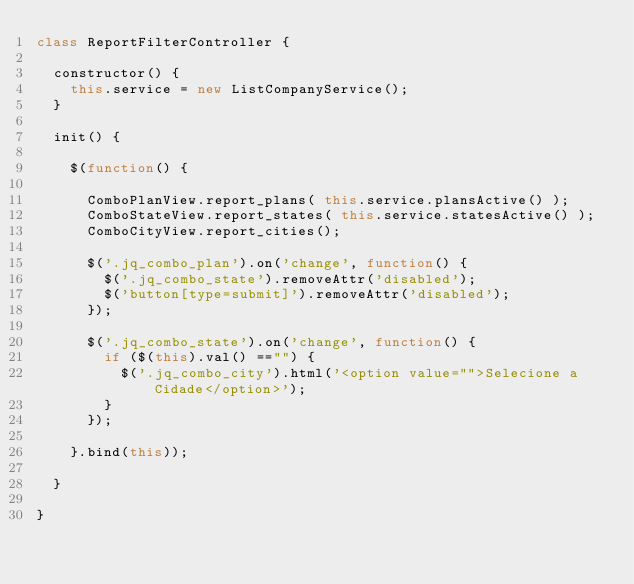Convert code to text. <code><loc_0><loc_0><loc_500><loc_500><_JavaScript_>class ReportFilterController {

	constructor() {
		this.service = new ListCompanyService();
	}

	init() {

		$(function() {

			ComboPlanView.report_plans( this.service.plansActive() );
			ComboStateView.report_states( this.service.statesActive() );
			ComboCityView.report_cities();

			$('.jq_combo_plan').on('change', function() {
				$('.jq_combo_state').removeAttr('disabled');
				$('button[type=submit]').removeAttr('disabled');
			});

			$('.jq_combo_state').on('change', function() {
				if ($(this).val() =="") {
					$('.jq_combo_city').html('<option value="">Selecione a Cidade</option>');
				}
			});

		}.bind(this));

	}

}
</code> 